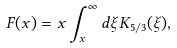<formula> <loc_0><loc_0><loc_500><loc_500>F ( x ) = x \int _ { x } ^ { \infty } d \xi K _ { 5 / 3 } ( \xi ) ,</formula> 